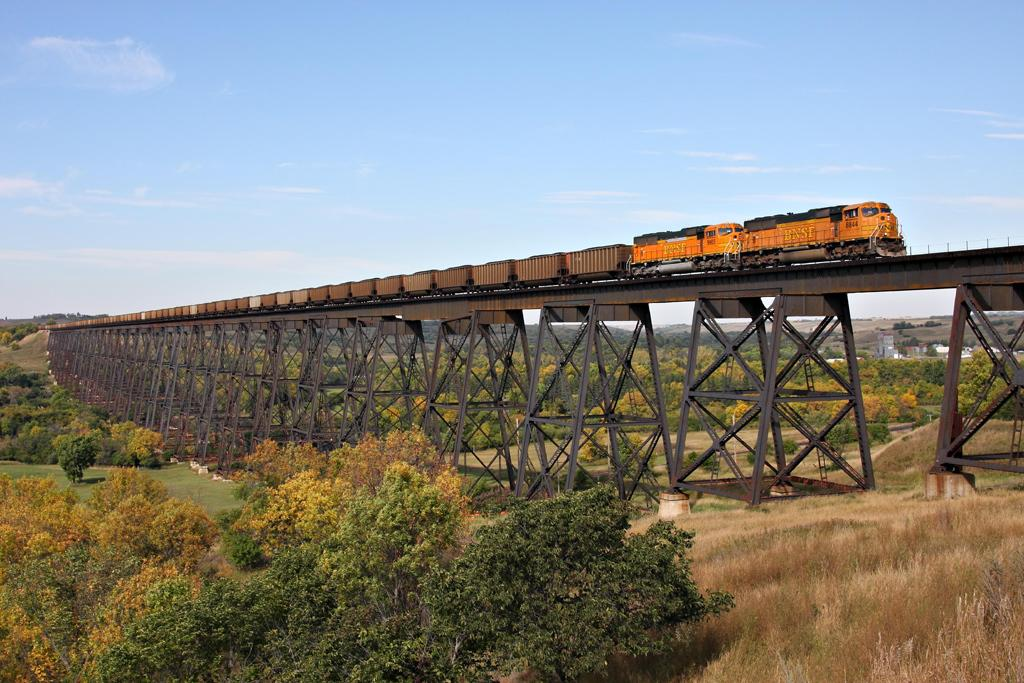What type of train is in the picture? There is a goods train in the picture. What structure can be seen in the picture? There is a bridge in the picture. What type of vegetation is present in the picture? There are trees in the picture. What can be seen in the sky in the picture? There are clouds visible in the sky. What type of acoustics can be heard from the train in the image? There is no information about the acoustics of the train in the image, as it only shows a visual representation of the train. 